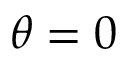<formula> <loc_0><loc_0><loc_500><loc_500>\theta = 0</formula> 